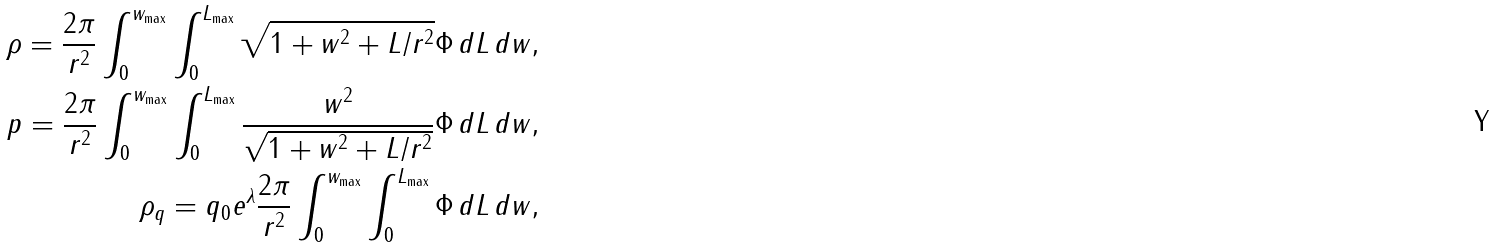<formula> <loc_0><loc_0><loc_500><loc_500>\rho = \frac { 2 \pi } { r ^ { 2 } } \int _ { 0 } ^ { w _ { \max } } \int _ { 0 } ^ { L _ { \max } } \sqrt { 1 + w ^ { 2 } + L / r ^ { 2 } } \Phi \, d L \, d w , \\ p = \frac { 2 \pi } { r ^ { 2 } } \int _ { 0 } ^ { w _ { \max } } \int _ { 0 } ^ { L _ { \max } } \frac { w ^ { 2 } } { \sqrt { 1 + w ^ { 2 } + L / r ^ { 2 } } } \Phi \, d L \, d w , \\ \rho _ { q } = q _ { 0 } e ^ { \lambda } \frac { 2 \pi } { r ^ { 2 } } \int _ { 0 } ^ { w _ { \max } } \int _ { 0 } ^ { L _ { \max } } \Phi \, d L \, d w ,</formula> 